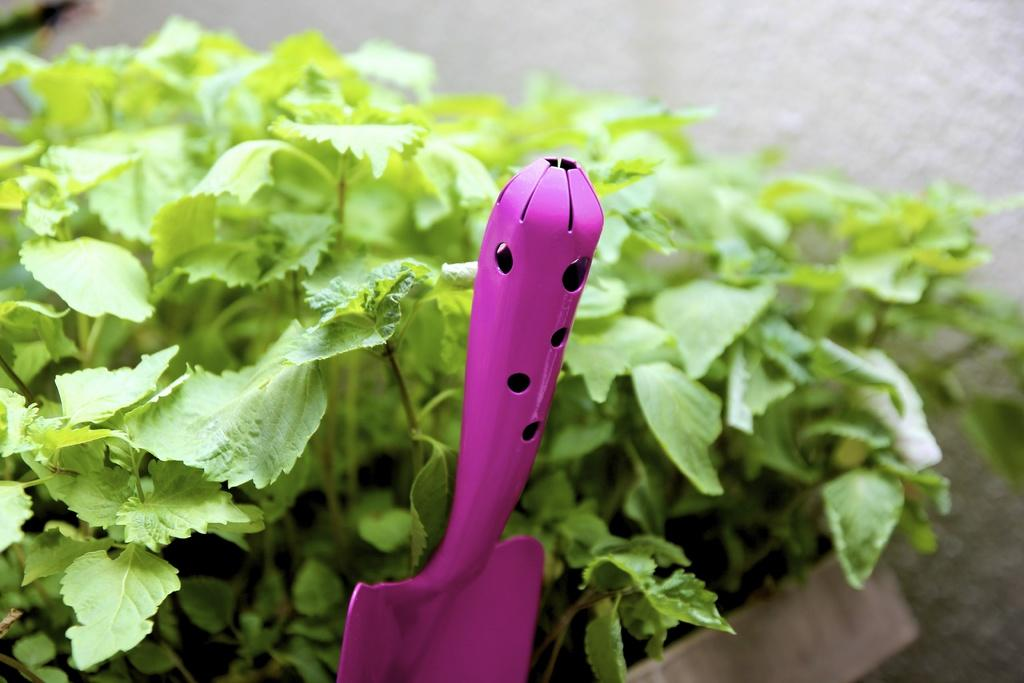What type of living organisms can be seen in the image? Plants can be seen in the image. What tool is visible in the image? There is a shovel in the image. Can you describe the quality of the top part of the image? The top part of the image is blurred. What type of thing is the minister reading in the image? There is no minister or any reading material present in the image. 